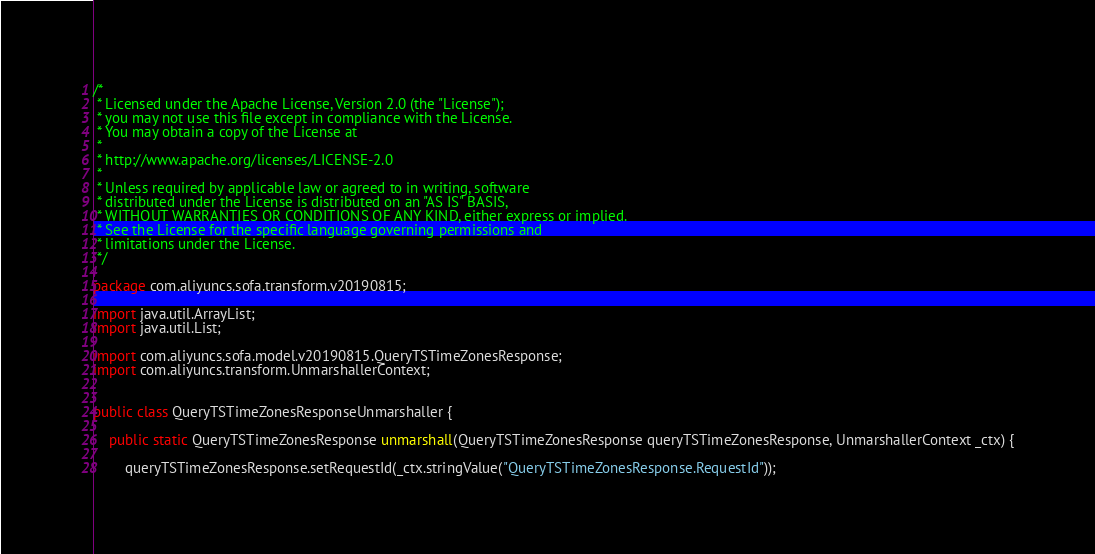Convert code to text. <code><loc_0><loc_0><loc_500><loc_500><_Java_>/*
 * Licensed under the Apache License, Version 2.0 (the "License");
 * you may not use this file except in compliance with the License.
 * You may obtain a copy of the License at
 *
 * http://www.apache.org/licenses/LICENSE-2.0
 *
 * Unless required by applicable law or agreed to in writing, software
 * distributed under the License is distributed on an "AS IS" BASIS,
 * WITHOUT WARRANTIES OR CONDITIONS OF ANY KIND, either express or implied.
 * See the License for the specific language governing permissions and
 * limitations under the License.
 */

package com.aliyuncs.sofa.transform.v20190815;

import java.util.ArrayList;
import java.util.List;

import com.aliyuncs.sofa.model.v20190815.QueryTSTimeZonesResponse;
import com.aliyuncs.transform.UnmarshallerContext;


public class QueryTSTimeZonesResponseUnmarshaller {

	public static QueryTSTimeZonesResponse unmarshall(QueryTSTimeZonesResponse queryTSTimeZonesResponse, UnmarshallerContext _ctx) {
		
		queryTSTimeZonesResponse.setRequestId(_ctx.stringValue("QueryTSTimeZonesResponse.RequestId"));</code> 